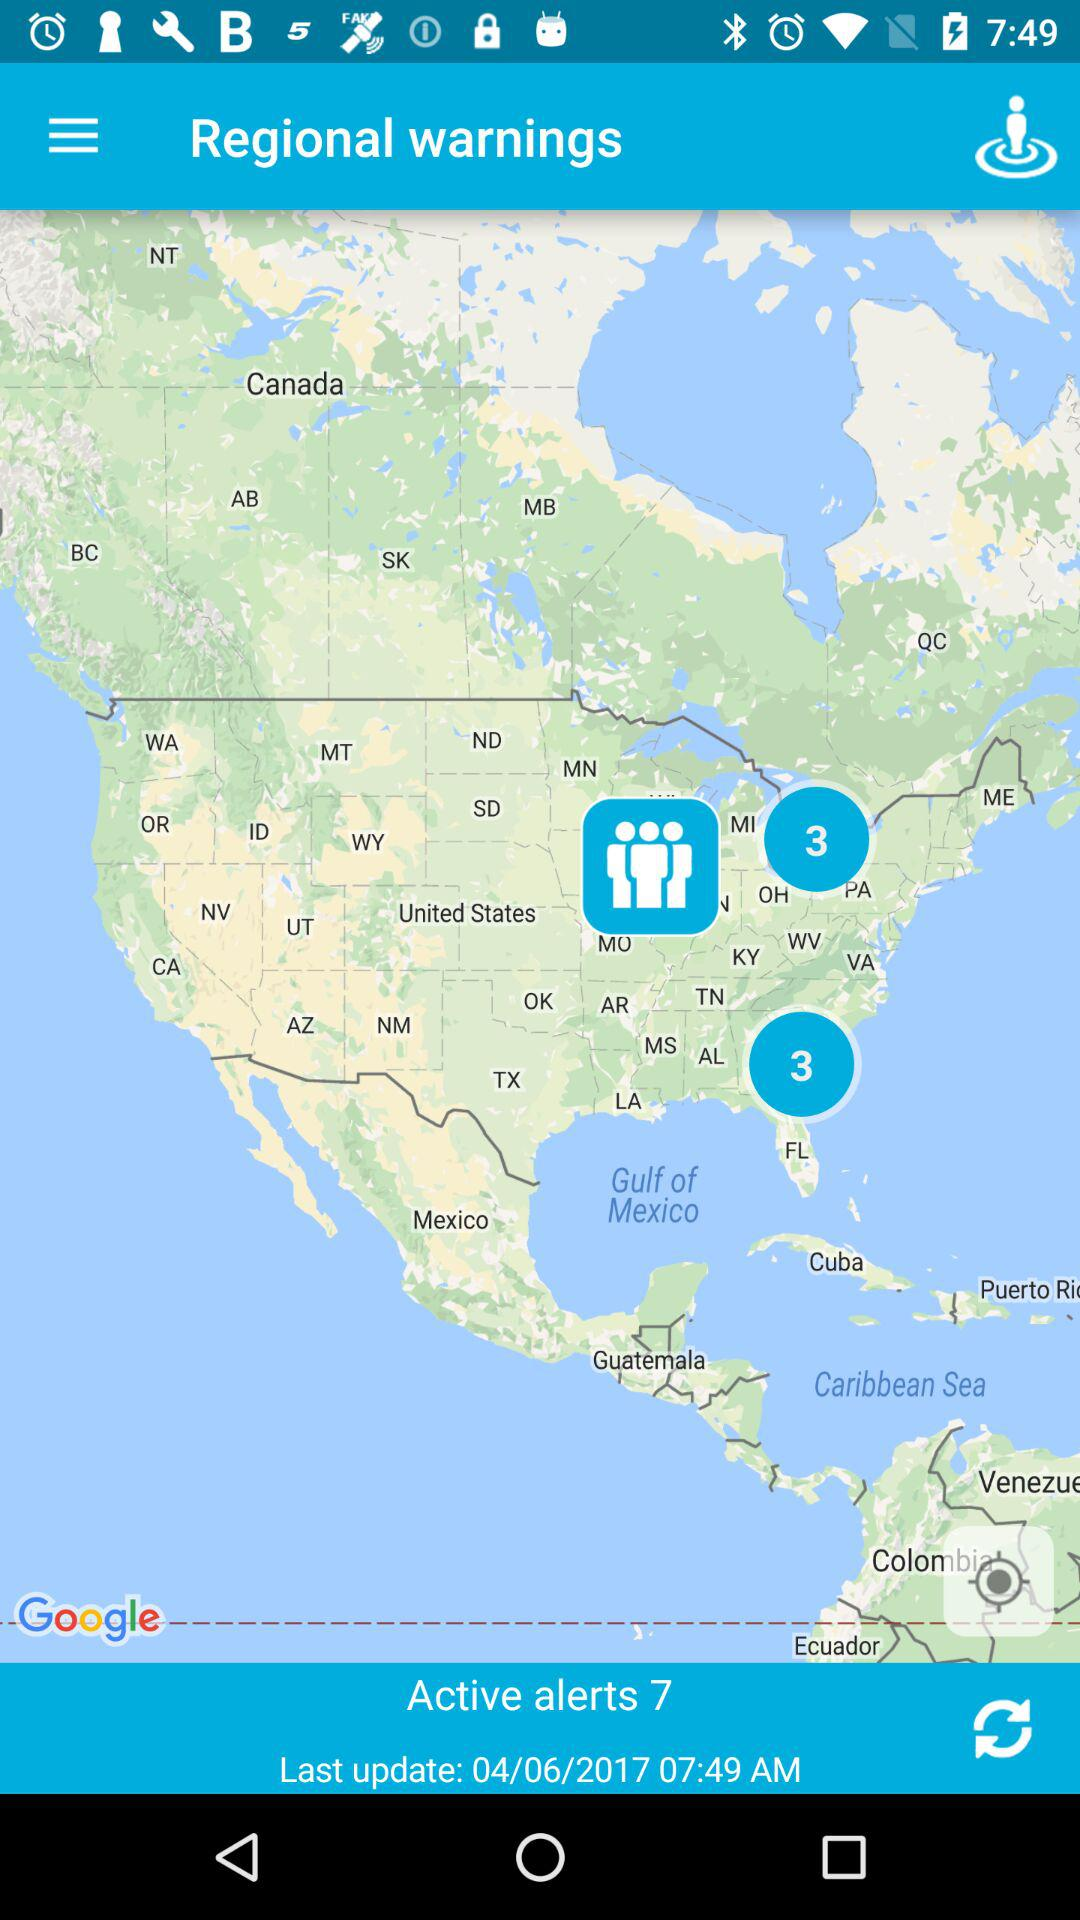When was it last updated? It was last updated on 04/06/2017 at 07:49 AM. 